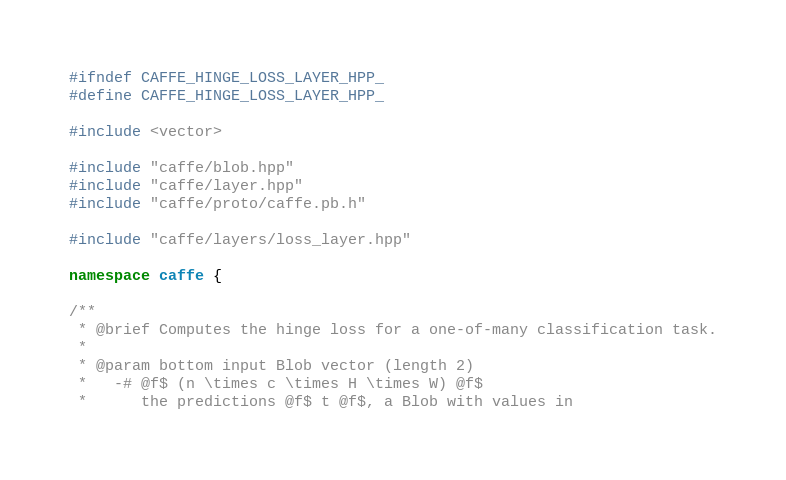Convert code to text. <code><loc_0><loc_0><loc_500><loc_500><_C++_>#ifndef CAFFE_HINGE_LOSS_LAYER_HPP_
#define CAFFE_HINGE_LOSS_LAYER_HPP_

#include <vector>

#include "caffe/blob.hpp"
#include "caffe/layer.hpp"
#include "caffe/proto/caffe.pb.h"

#include "caffe/layers/loss_layer.hpp"

namespace caffe {

/**
 * @brief Computes the hinge loss for a one-of-many classification task.
 *
 * @param bottom input Blob vector (length 2)
 *   -# @f$ (n \times c \times H \times W) @f$
 *      the predictions @f$ t @f$, a Blob with values in</code> 